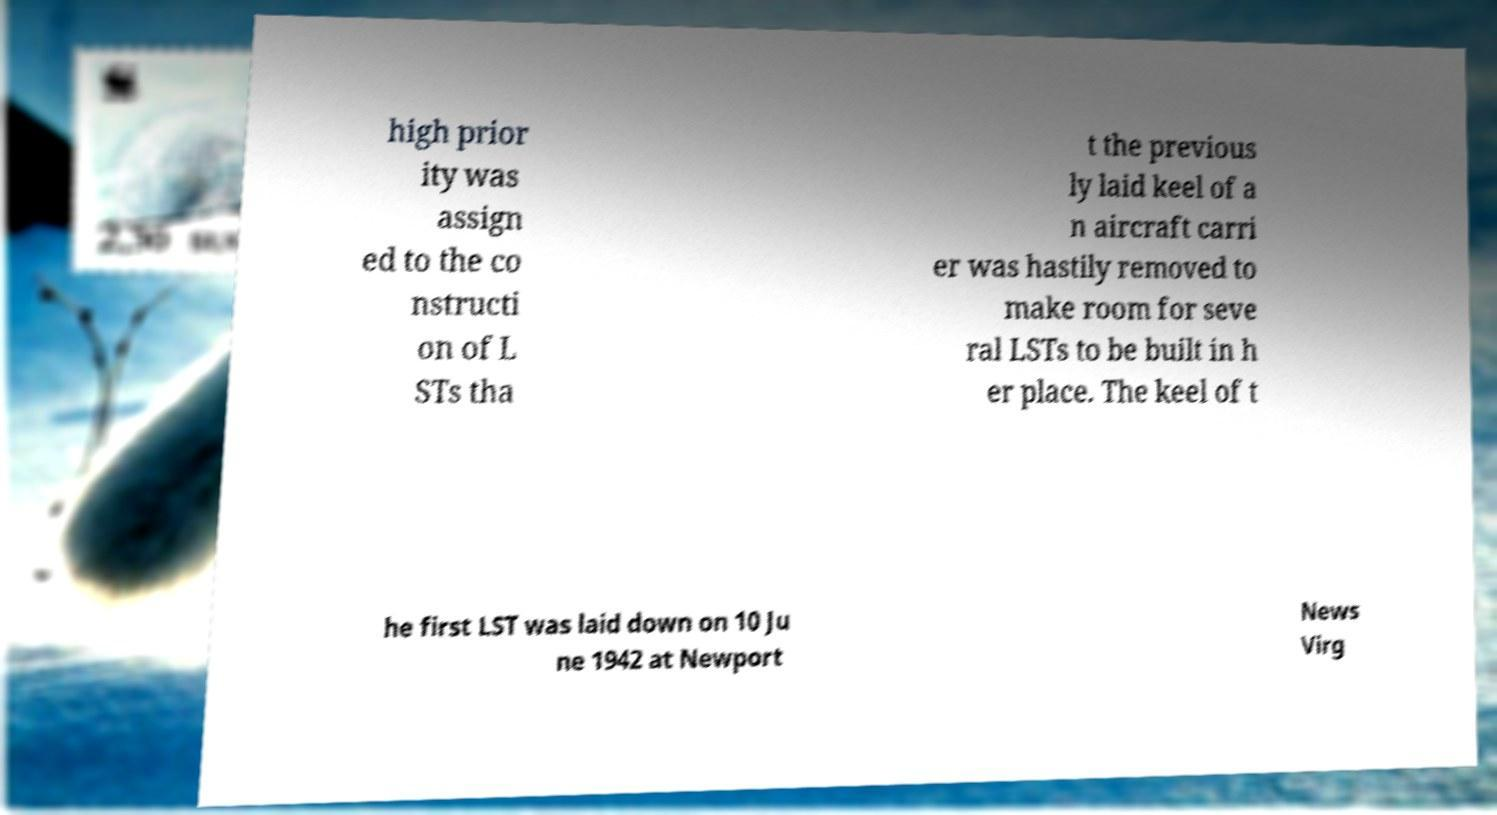Please identify and transcribe the text found in this image. high prior ity was assign ed to the co nstructi on of L STs tha t the previous ly laid keel of a n aircraft carri er was hastily removed to make room for seve ral LSTs to be built in h er place. The keel of t he first LST was laid down on 10 Ju ne 1942 at Newport News Virg 